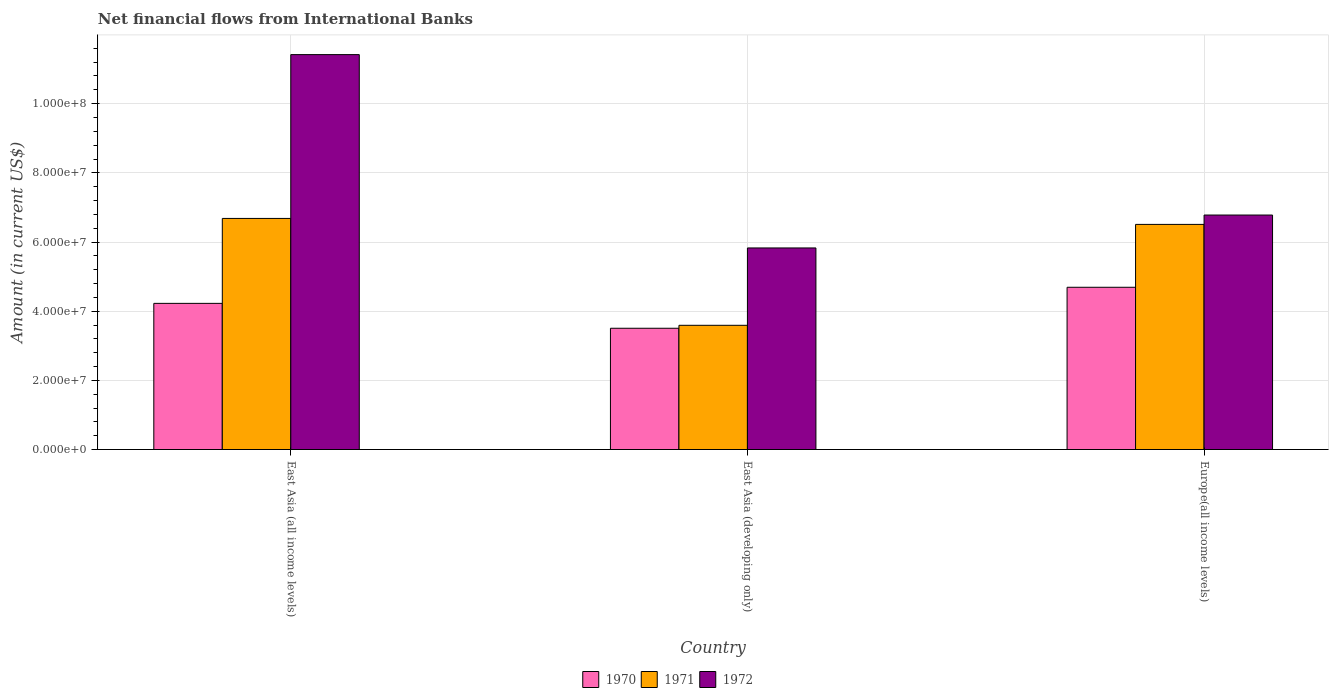How many groups of bars are there?
Give a very brief answer. 3. Are the number of bars per tick equal to the number of legend labels?
Make the answer very short. Yes. How many bars are there on the 2nd tick from the left?
Your response must be concise. 3. What is the label of the 3rd group of bars from the left?
Offer a terse response. Europe(all income levels). What is the net financial aid flows in 1971 in East Asia (developing only)?
Provide a short and direct response. 3.59e+07. Across all countries, what is the maximum net financial aid flows in 1971?
Ensure brevity in your answer.  6.68e+07. Across all countries, what is the minimum net financial aid flows in 1970?
Provide a short and direct response. 3.51e+07. In which country was the net financial aid flows in 1972 maximum?
Offer a very short reply. East Asia (all income levels). In which country was the net financial aid flows in 1970 minimum?
Ensure brevity in your answer.  East Asia (developing only). What is the total net financial aid flows in 1972 in the graph?
Offer a very short reply. 2.40e+08. What is the difference between the net financial aid flows in 1970 in East Asia (developing only) and that in Europe(all income levels)?
Your answer should be very brief. -1.19e+07. What is the difference between the net financial aid flows in 1972 in East Asia (developing only) and the net financial aid flows in 1971 in East Asia (all income levels)?
Give a very brief answer. -8.53e+06. What is the average net financial aid flows in 1971 per country?
Make the answer very short. 5.59e+07. What is the difference between the net financial aid flows of/in 1970 and net financial aid flows of/in 1971 in Europe(all income levels)?
Offer a terse response. -1.82e+07. In how many countries, is the net financial aid flows in 1971 greater than 72000000 US$?
Ensure brevity in your answer.  0. What is the ratio of the net financial aid flows in 1971 in East Asia (all income levels) to that in East Asia (developing only)?
Your answer should be compact. 1.86. Is the net financial aid flows in 1972 in East Asia (all income levels) less than that in East Asia (developing only)?
Your response must be concise. No. What is the difference between the highest and the second highest net financial aid flows in 1971?
Offer a very short reply. 3.09e+07. What is the difference between the highest and the lowest net financial aid flows in 1971?
Provide a short and direct response. 3.09e+07. In how many countries, is the net financial aid flows in 1970 greater than the average net financial aid flows in 1970 taken over all countries?
Provide a succinct answer. 2. What does the 1st bar from the left in East Asia (developing only) represents?
Your answer should be very brief. 1970. How many bars are there?
Make the answer very short. 9. What is the difference between two consecutive major ticks on the Y-axis?
Make the answer very short. 2.00e+07. Are the values on the major ticks of Y-axis written in scientific E-notation?
Offer a very short reply. Yes. Does the graph contain any zero values?
Offer a very short reply. No. How many legend labels are there?
Provide a short and direct response. 3. What is the title of the graph?
Keep it short and to the point. Net financial flows from International Banks. Does "1999" appear as one of the legend labels in the graph?
Make the answer very short. No. What is the label or title of the X-axis?
Provide a short and direct response. Country. What is the label or title of the Y-axis?
Your answer should be very brief. Amount (in current US$). What is the Amount (in current US$) of 1970 in East Asia (all income levels)?
Offer a terse response. 4.23e+07. What is the Amount (in current US$) in 1971 in East Asia (all income levels)?
Ensure brevity in your answer.  6.68e+07. What is the Amount (in current US$) in 1972 in East Asia (all income levels)?
Provide a succinct answer. 1.14e+08. What is the Amount (in current US$) in 1970 in East Asia (developing only)?
Provide a short and direct response. 3.51e+07. What is the Amount (in current US$) in 1971 in East Asia (developing only)?
Your response must be concise. 3.59e+07. What is the Amount (in current US$) of 1972 in East Asia (developing only)?
Ensure brevity in your answer.  5.83e+07. What is the Amount (in current US$) of 1970 in Europe(all income levels)?
Your answer should be very brief. 4.69e+07. What is the Amount (in current US$) in 1971 in Europe(all income levels)?
Your response must be concise. 6.51e+07. What is the Amount (in current US$) of 1972 in Europe(all income levels)?
Ensure brevity in your answer.  6.78e+07. Across all countries, what is the maximum Amount (in current US$) of 1970?
Your answer should be compact. 4.69e+07. Across all countries, what is the maximum Amount (in current US$) of 1971?
Your answer should be compact. 6.68e+07. Across all countries, what is the maximum Amount (in current US$) of 1972?
Your answer should be very brief. 1.14e+08. Across all countries, what is the minimum Amount (in current US$) of 1970?
Keep it short and to the point. 3.51e+07. Across all countries, what is the minimum Amount (in current US$) in 1971?
Your answer should be very brief. 3.59e+07. Across all countries, what is the minimum Amount (in current US$) of 1972?
Your answer should be compact. 5.83e+07. What is the total Amount (in current US$) in 1970 in the graph?
Offer a very short reply. 1.24e+08. What is the total Amount (in current US$) in 1971 in the graph?
Provide a succinct answer. 1.68e+08. What is the total Amount (in current US$) in 1972 in the graph?
Keep it short and to the point. 2.40e+08. What is the difference between the Amount (in current US$) of 1970 in East Asia (all income levels) and that in East Asia (developing only)?
Make the answer very short. 7.20e+06. What is the difference between the Amount (in current US$) of 1971 in East Asia (all income levels) and that in East Asia (developing only)?
Keep it short and to the point. 3.09e+07. What is the difference between the Amount (in current US$) of 1972 in East Asia (all income levels) and that in East Asia (developing only)?
Your response must be concise. 5.59e+07. What is the difference between the Amount (in current US$) in 1970 in East Asia (all income levels) and that in Europe(all income levels)?
Make the answer very short. -4.65e+06. What is the difference between the Amount (in current US$) in 1971 in East Asia (all income levels) and that in Europe(all income levels)?
Give a very brief answer. 1.72e+06. What is the difference between the Amount (in current US$) in 1972 in East Asia (all income levels) and that in Europe(all income levels)?
Offer a terse response. 4.64e+07. What is the difference between the Amount (in current US$) in 1970 in East Asia (developing only) and that in Europe(all income levels)?
Ensure brevity in your answer.  -1.19e+07. What is the difference between the Amount (in current US$) of 1971 in East Asia (developing only) and that in Europe(all income levels)?
Your answer should be very brief. -2.92e+07. What is the difference between the Amount (in current US$) of 1972 in East Asia (developing only) and that in Europe(all income levels)?
Provide a succinct answer. -9.52e+06. What is the difference between the Amount (in current US$) of 1970 in East Asia (all income levels) and the Amount (in current US$) of 1971 in East Asia (developing only)?
Ensure brevity in your answer.  6.34e+06. What is the difference between the Amount (in current US$) in 1970 in East Asia (all income levels) and the Amount (in current US$) in 1972 in East Asia (developing only)?
Offer a terse response. -1.60e+07. What is the difference between the Amount (in current US$) in 1971 in East Asia (all income levels) and the Amount (in current US$) in 1972 in East Asia (developing only)?
Ensure brevity in your answer.  8.53e+06. What is the difference between the Amount (in current US$) of 1970 in East Asia (all income levels) and the Amount (in current US$) of 1971 in Europe(all income levels)?
Keep it short and to the point. -2.28e+07. What is the difference between the Amount (in current US$) of 1970 in East Asia (all income levels) and the Amount (in current US$) of 1972 in Europe(all income levels)?
Your answer should be compact. -2.55e+07. What is the difference between the Amount (in current US$) of 1971 in East Asia (all income levels) and the Amount (in current US$) of 1972 in Europe(all income levels)?
Make the answer very short. -9.81e+05. What is the difference between the Amount (in current US$) of 1970 in East Asia (developing only) and the Amount (in current US$) of 1971 in Europe(all income levels)?
Provide a short and direct response. -3.00e+07. What is the difference between the Amount (in current US$) of 1970 in East Asia (developing only) and the Amount (in current US$) of 1972 in Europe(all income levels)?
Provide a short and direct response. -3.27e+07. What is the difference between the Amount (in current US$) in 1971 in East Asia (developing only) and the Amount (in current US$) in 1972 in Europe(all income levels)?
Ensure brevity in your answer.  -3.19e+07. What is the average Amount (in current US$) in 1970 per country?
Offer a terse response. 4.14e+07. What is the average Amount (in current US$) in 1971 per country?
Provide a succinct answer. 5.59e+07. What is the average Amount (in current US$) of 1972 per country?
Keep it short and to the point. 8.01e+07. What is the difference between the Amount (in current US$) in 1970 and Amount (in current US$) in 1971 in East Asia (all income levels)?
Offer a very short reply. -2.46e+07. What is the difference between the Amount (in current US$) in 1970 and Amount (in current US$) in 1972 in East Asia (all income levels)?
Give a very brief answer. -7.19e+07. What is the difference between the Amount (in current US$) in 1971 and Amount (in current US$) in 1972 in East Asia (all income levels)?
Your response must be concise. -4.74e+07. What is the difference between the Amount (in current US$) of 1970 and Amount (in current US$) of 1971 in East Asia (developing only)?
Offer a terse response. -8.55e+05. What is the difference between the Amount (in current US$) of 1970 and Amount (in current US$) of 1972 in East Asia (developing only)?
Make the answer very short. -2.32e+07. What is the difference between the Amount (in current US$) in 1971 and Amount (in current US$) in 1972 in East Asia (developing only)?
Your response must be concise. -2.24e+07. What is the difference between the Amount (in current US$) in 1970 and Amount (in current US$) in 1971 in Europe(all income levels)?
Make the answer very short. -1.82e+07. What is the difference between the Amount (in current US$) in 1970 and Amount (in current US$) in 1972 in Europe(all income levels)?
Keep it short and to the point. -2.09e+07. What is the difference between the Amount (in current US$) of 1971 and Amount (in current US$) of 1972 in Europe(all income levels)?
Give a very brief answer. -2.70e+06. What is the ratio of the Amount (in current US$) of 1970 in East Asia (all income levels) to that in East Asia (developing only)?
Keep it short and to the point. 1.21. What is the ratio of the Amount (in current US$) of 1971 in East Asia (all income levels) to that in East Asia (developing only)?
Give a very brief answer. 1.86. What is the ratio of the Amount (in current US$) in 1972 in East Asia (all income levels) to that in East Asia (developing only)?
Offer a terse response. 1.96. What is the ratio of the Amount (in current US$) in 1970 in East Asia (all income levels) to that in Europe(all income levels)?
Make the answer very short. 0.9. What is the ratio of the Amount (in current US$) of 1971 in East Asia (all income levels) to that in Europe(all income levels)?
Give a very brief answer. 1.03. What is the ratio of the Amount (in current US$) in 1972 in East Asia (all income levels) to that in Europe(all income levels)?
Keep it short and to the point. 1.68. What is the ratio of the Amount (in current US$) in 1970 in East Asia (developing only) to that in Europe(all income levels)?
Give a very brief answer. 0.75. What is the ratio of the Amount (in current US$) in 1971 in East Asia (developing only) to that in Europe(all income levels)?
Offer a terse response. 0.55. What is the ratio of the Amount (in current US$) of 1972 in East Asia (developing only) to that in Europe(all income levels)?
Make the answer very short. 0.86. What is the difference between the highest and the second highest Amount (in current US$) of 1970?
Provide a short and direct response. 4.65e+06. What is the difference between the highest and the second highest Amount (in current US$) in 1971?
Make the answer very short. 1.72e+06. What is the difference between the highest and the second highest Amount (in current US$) of 1972?
Keep it short and to the point. 4.64e+07. What is the difference between the highest and the lowest Amount (in current US$) in 1970?
Give a very brief answer. 1.19e+07. What is the difference between the highest and the lowest Amount (in current US$) of 1971?
Keep it short and to the point. 3.09e+07. What is the difference between the highest and the lowest Amount (in current US$) of 1972?
Make the answer very short. 5.59e+07. 